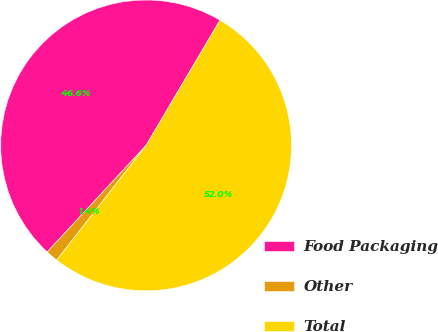Convert chart to OTSL. <chart><loc_0><loc_0><loc_500><loc_500><pie_chart><fcel>Food Packaging<fcel>Other<fcel>Total<nl><fcel>46.58%<fcel>1.37%<fcel>52.05%<nl></chart> 